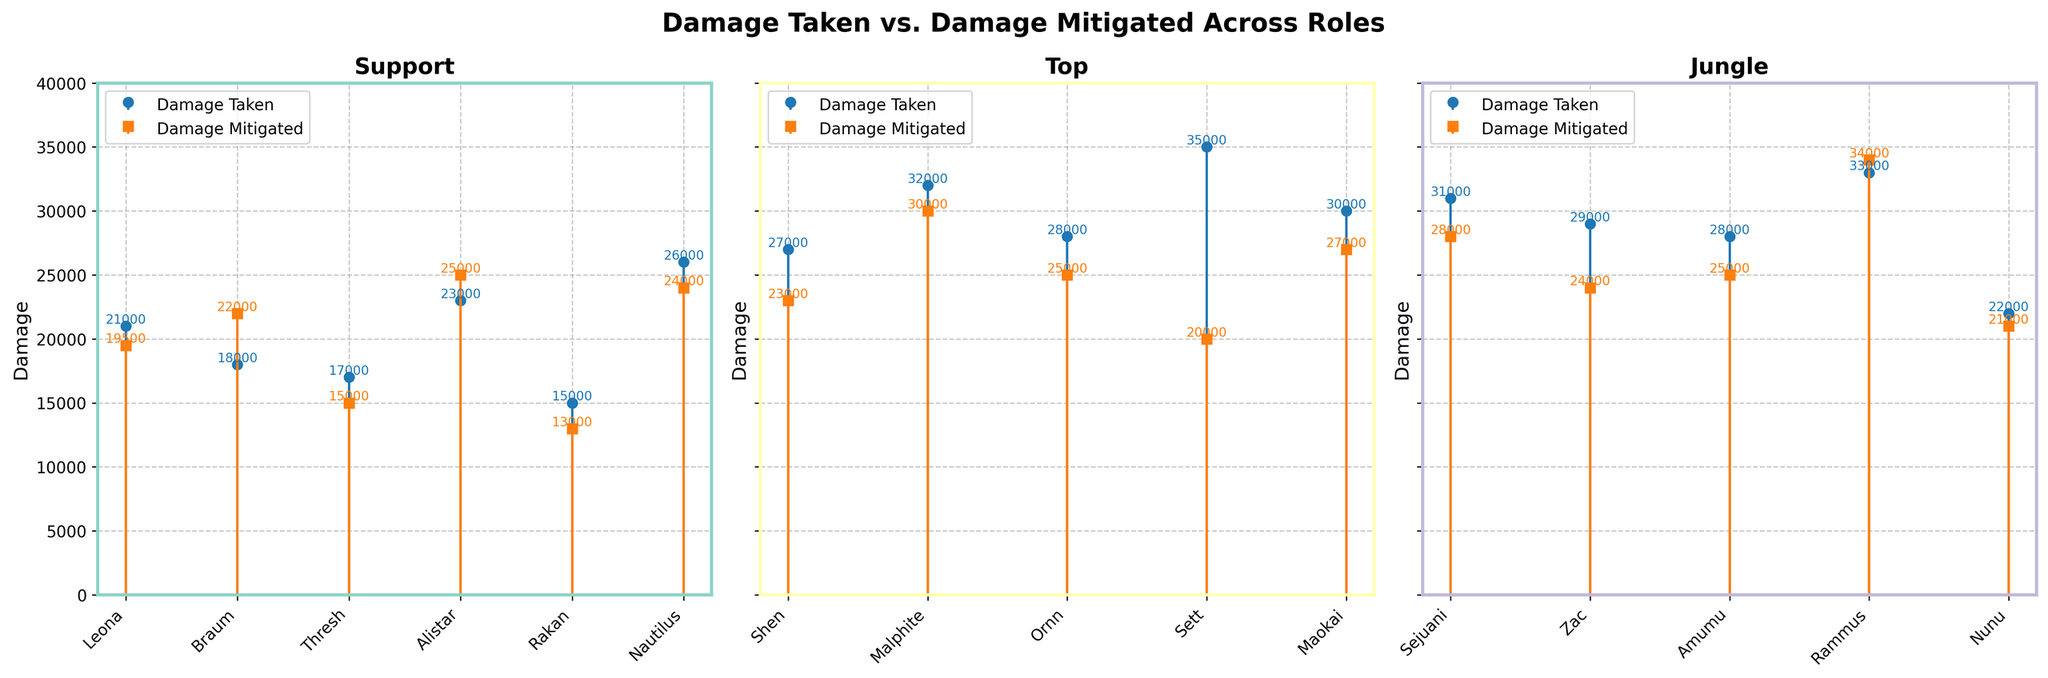What is the total damage taken by Support role champions? To find the total damage taken by Support champions, add the damage taken values for Leona, Braum, Thresh, Alistar, Rakan, and Nautilus: 21000 + 18000 + 17000 + 23000 + 15000 + 26000 = 120000
Answer: 120000 Which champion has the highest damage mitigated in the Support role? Compare the damage mitigated values of the Support champions: Leona (19500), Braum (22000), Thresh (15000), Alistar (25000), Rakan (13000), and Nautilus (24000). The highest value is for Alistar with 25000
Answer: Alistar What is the difference between the highest and lowest damage taken values in the Top role? Identify the highest and lowest damage taken values among Shen (27000), Malphite (32000), Ornn (28000), Sett (35000), and Maokai (30000). The highest is 35000 (Sett) and the lowest is 27000 (Shen). The difference is 35000 - 27000 = 8000
Answer: 8000 Does any champion in the Jungle role have their damage mitigated higher than their damage taken? If so, who? Check the damage taken and mitigated values for Jungle champions: Sejuani (31000, 28000), Zac (29000, 24000), Amumu (28000, 25000), Rammus (33000, 34000), and Nunu (22000, 21000). Rammus has higher damage mitigated (34000) than taken (33000)
Answer: Rammus Which Support role champion has the smallest difference between damage taken and damage mitigated? Calculate the difference between damage taken and mitigated for Support champions: Leona (1500), Braum (-4000), Thresh (2000), Alistar (-2000), Rakan (2000), Nautilus (2000). The smallest absolute difference is for Leona (1500)
Answer: Leona Among the Top role champions, who has the highest ratio of damage taken to damage mitigated? Calculate the ratio of damage taken to mitigated for Top champions: Shen (27000/23000 ≈ 1.17), Malphite (32000/30000 ≈ 1.07), Ornn (28000/25000 = 1.12), Sett (35000/20000 = 1.75), and Maokai (30000/27000 ≈ 1.11). The highest ratio is for Sett (1.75)
Answer: Sett Considering all roles, which champion has the highest damage taken value? Examine the highest damage taken values across all champions and roles: Sett (35000 in Top)
Answer: Sett What is the average damage mitigated in the Jungle role? Calculate the average damage mitigated for Jungle champions: (28000 + 24000 + 25000 + 34000 + 21000) / 5 = 26400
Answer: 26400 